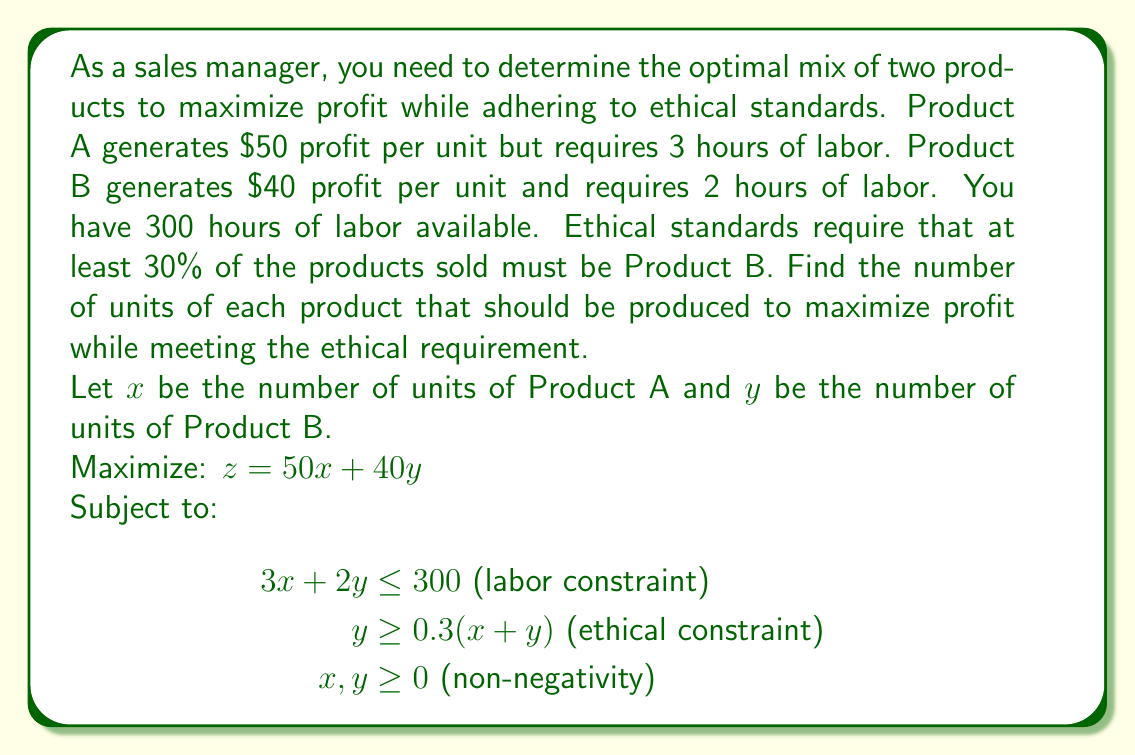What is the answer to this math problem? 1. Simplify the ethical constraint:
   $y \geq 0.3(x + y)$
   $y \geq 0.3x + 0.3y$
   $0.7y \geq 0.3x$
   $y \geq \frac{3}{7}x$

2. Graph the constraints:
   Labor constraint: $3x + 2y = 300$
   Ethical constraint: $y = \frac{3}{7}x$

3. Find the intersection points:
   $3x + 2y = 300$ and $y = \frac{3}{7}x$
   $3x + 2(\frac{3}{7}x) = 300$
   $3x + \frac{6}{7}x = 300$
   $\frac{21}{7}x + \frac{6}{7}x = 300$
   $\frac{27}{7}x = 300$
   $x = \frac{300 \cdot 7}{27} = 77.78$
   $y = \frac{3}{7} \cdot 77.78 = 33.33$

4. Check the corner points:
   (0, 150), (77.78, 33.33), (100, 0)

5. Evaluate the objective function at these points:
   $z(0, 150) = 50(0) + 40(150) = 6000$
   $z(77.78, 33.33) = 50(77.78) + 40(33.33) = 5222.2$
   $z(100, 0) = 50(100) + 40(0) = 5000$

6. The maximum profit is achieved at (0, 150), but this doesn't meet the ethical constraint.
   The optimal solution that meets all constraints is (77.78, 33.33).

7. Round to whole numbers: 78 units of Product A and 33 units of Product B.
Answer: 78 units of Product A and 33 units of Product B 